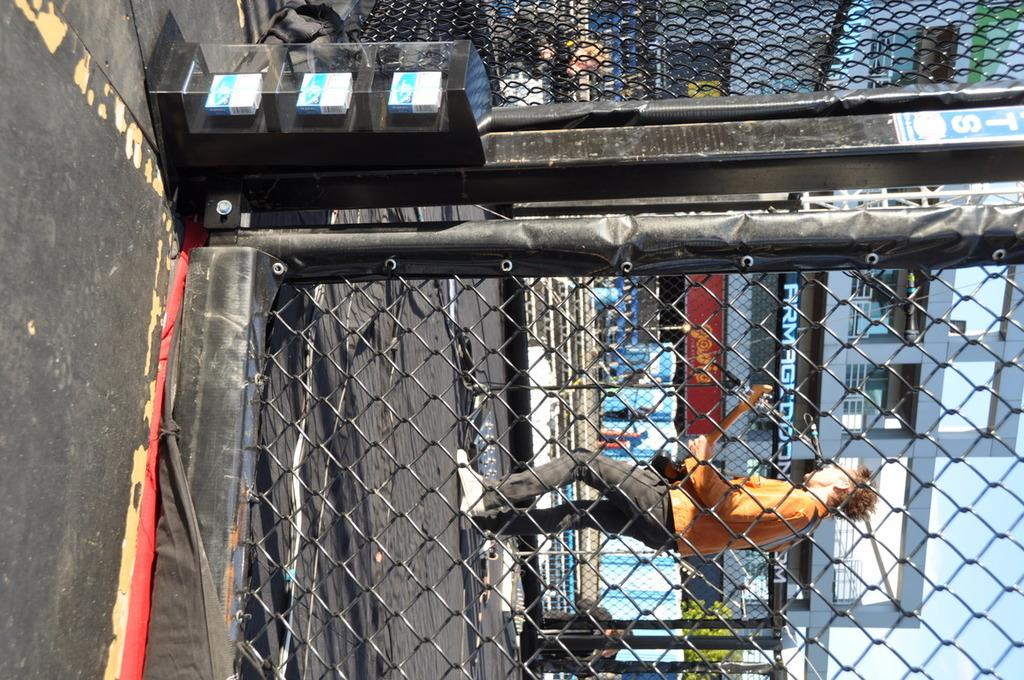What is the main object in the image? There is a mesh in the image. Who or what is inside the mesh? A person is standing inside the mesh. What is the person doing? The person is playing a guitar. What can be seen in the background of the image? There is a building in front of the person. How many stitches are visible on the person's shirt in the image? There is no information about the person's shirt or the number of stitches in the image. 